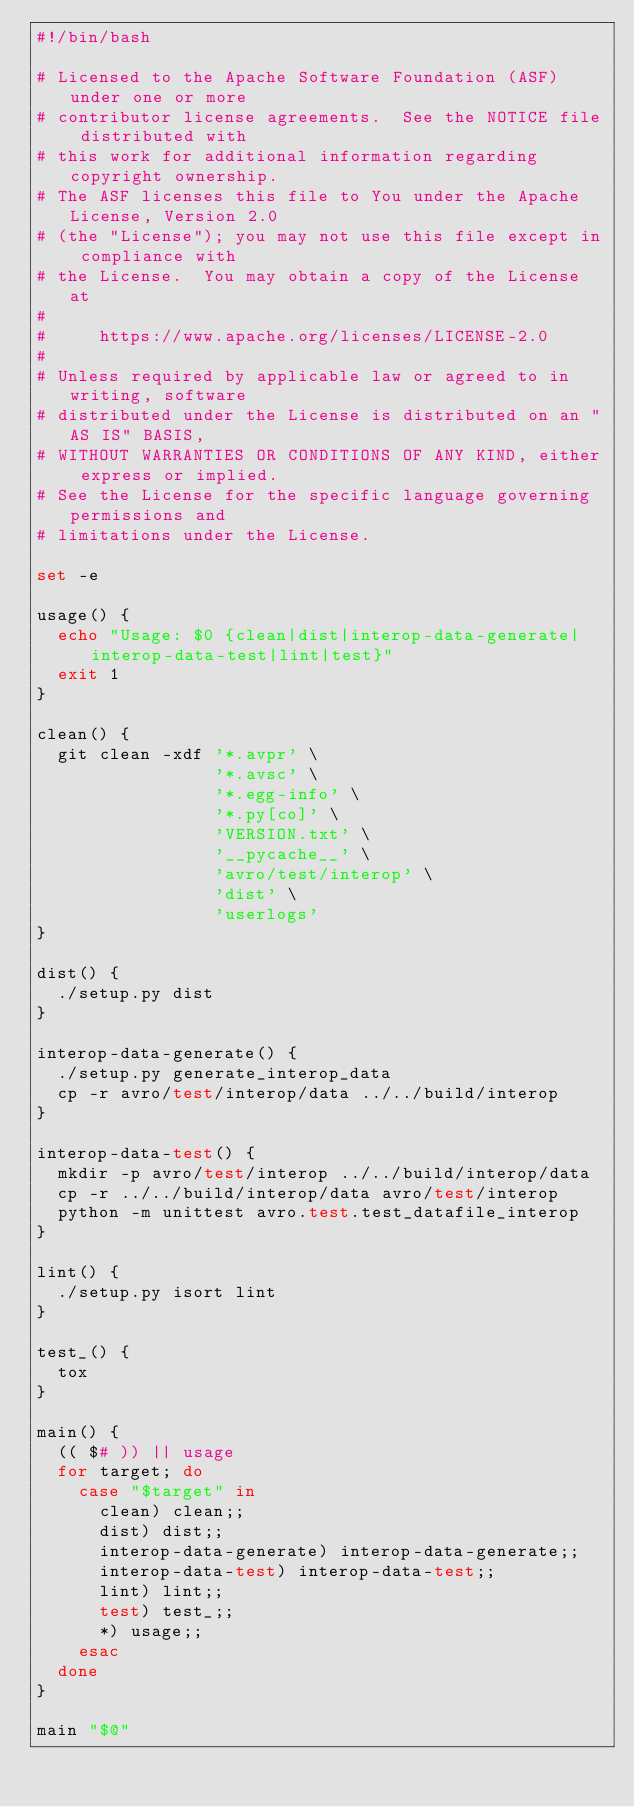Convert code to text. <code><loc_0><loc_0><loc_500><loc_500><_Bash_>#!/bin/bash

# Licensed to the Apache Software Foundation (ASF) under one or more
# contributor license agreements.  See the NOTICE file distributed with
# this work for additional information regarding copyright ownership.
# The ASF licenses this file to You under the Apache License, Version 2.0
# (the "License"); you may not use this file except in compliance with
# the License.  You may obtain a copy of the License at
#
#     https://www.apache.org/licenses/LICENSE-2.0
#
# Unless required by applicable law or agreed to in writing, software
# distributed under the License is distributed on an "AS IS" BASIS,
# WITHOUT WARRANTIES OR CONDITIONS OF ANY KIND, either express or implied.
# See the License for the specific language governing permissions and
# limitations under the License.

set -e

usage() {
  echo "Usage: $0 {clean|dist|interop-data-generate|interop-data-test|lint|test}"
  exit 1
}

clean() {
  git clean -xdf '*.avpr' \
                 '*.avsc' \
                 '*.egg-info' \
                 '*.py[co]' \
                 'VERSION.txt' \
                 '__pycache__' \
                 'avro/test/interop' \
                 'dist' \
                 'userlogs'
}

dist() {
  ./setup.py dist
}

interop-data-generate() {
  ./setup.py generate_interop_data
  cp -r avro/test/interop/data ../../build/interop
}

interop-data-test() {
  mkdir -p avro/test/interop ../../build/interop/data
  cp -r ../../build/interop/data avro/test/interop
  python -m unittest avro.test.test_datafile_interop
}

lint() {
  ./setup.py isort lint
}

test_() {
  tox
}

main() {
  (( $# )) || usage
  for target; do
    case "$target" in
      clean) clean;;
      dist) dist;;
      interop-data-generate) interop-data-generate;;
      interop-data-test) interop-data-test;;
      lint) lint;;
      test) test_;;
      *) usage;;
    esac
  done
}

main "$@"
</code> 